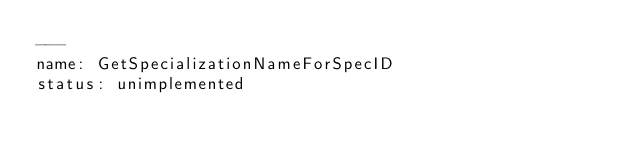<code> <loc_0><loc_0><loc_500><loc_500><_YAML_>---
name: GetSpecializationNameForSpecID
status: unimplemented
</code> 